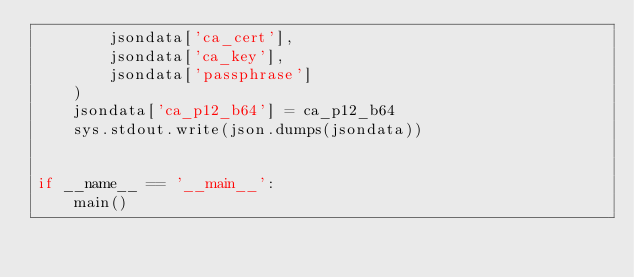<code> <loc_0><loc_0><loc_500><loc_500><_Python_>        jsondata['ca_cert'],
        jsondata['ca_key'],
        jsondata['passphrase']
    )
    jsondata['ca_p12_b64'] = ca_p12_b64
    sys.stdout.write(json.dumps(jsondata))


if __name__ == '__main__':
    main()
</code> 